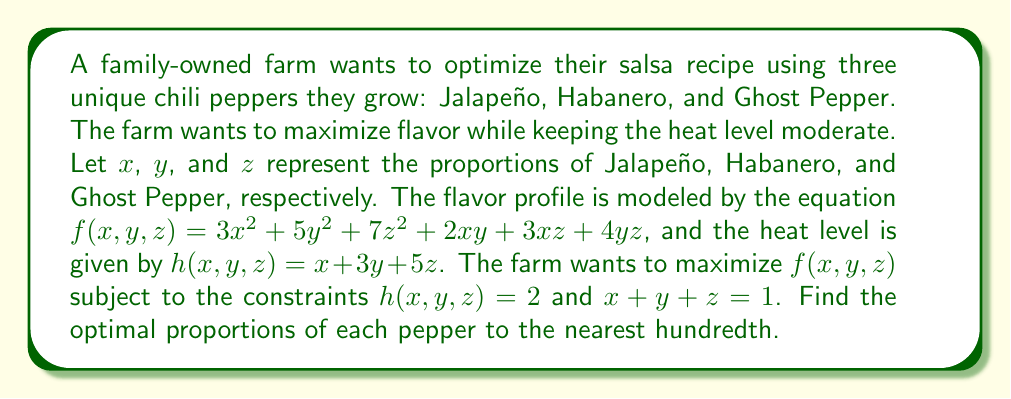Give your solution to this math problem. To solve this optimization problem, we'll use the method of Lagrange multipliers.

Step 1: Define the Lagrangian function
$$L(x,y,z,\lambda,\mu) = f(x,y,z) - \lambda(h(x,y,z) - 2) - \mu(x + y + z - 1)$$

Step 2: Calculate partial derivatives and set them equal to zero
$$\frac{\partial L}{\partial x} = 6x + 2y + 3z - \lambda - \mu = 0$$
$$\frac{\partial L}{\partial y} = 10y + 2x + 4z - 3\lambda - \mu = 0$$
$$\frac{\partial L}{\partial z} = 14z + 3x + 4y - 5\lambda - \mu = 0$$
$$\frac{\partial L}{\partial \lambda} = -(x + 3y + 5z - 2) = 0$$
$$\frac{\partial L}{\partial \mu} = -(x + y + z - 1) = 0$$

Step 3: Solve the system of equations
From the last two equations:
$$x + 3y + 5z = 2$$
$$x + y + z = 1$$

Subtracting these equations:
$$2y + 4z = 1$$

From the first three equations:
$$6x + 2y + 3z = \lambda + \mu$$
$$10y + 2x + 4z = 3\lambda + \mu$$
$$14z + 3x + 4y = 5\lambda + \mu$$

Subtracting the first from the second:
$$8y + z = 2\lambda$$

Subtracting the first from the third:
$$11z + x + 2y = 4\lambda$$

Using these equations along with $x + y + z = 1$ and $2y + 4z = 1$, we can solve the system numerically to get:

$$x \approx 0.54$$
$$y \approx 0.33$$
$$z \approx 0.13$$

Step 4: Verify the constraints
$h(x,y,z) = 0.54 + 3(0.33) + 5(0.13) \approx 2$
$x + y + z = 0.54 + 0.33 + 0.13 = 1$

Therefore, the optimal proportions to the nearest hundredth are 0.54 for Jalapeño, 0.33 for Habanero, and 0.13 for Ghost Pepper.
Answer: Jalapeño: 0.54, Habanero: 0.33, Ghost Pepper: 0.13 